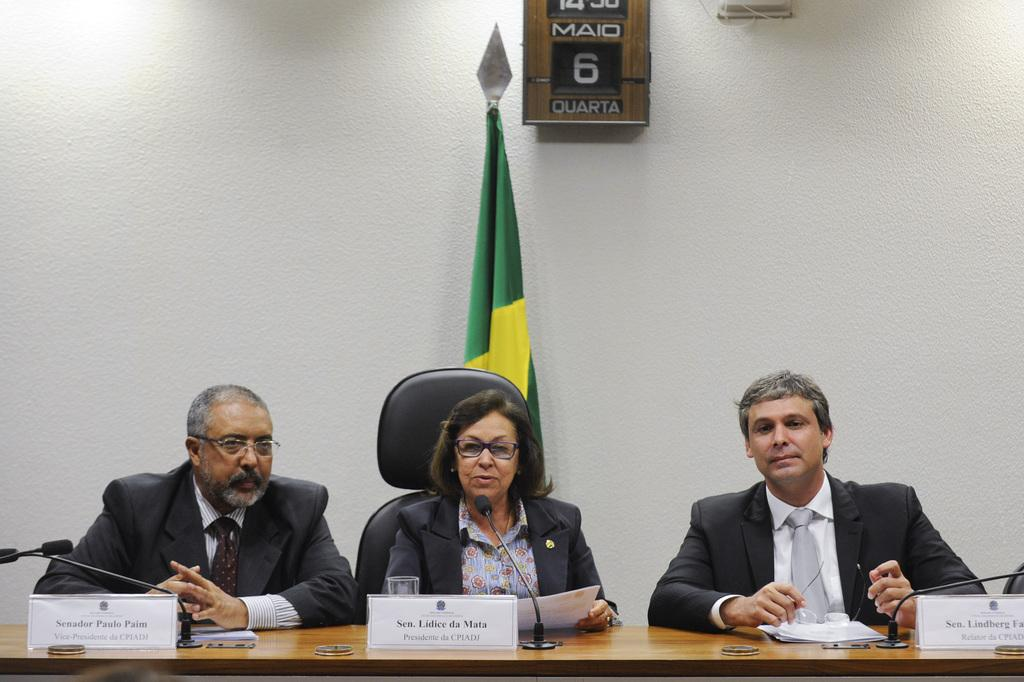How many people are in the image? There are three people in the image. What are the people doing in the image? The people are sitting on chairs. Where are the chairs located in relation to the desk? The chairs are in front of a desk. What items can be seen on the desk? There are name boards and microphones on the desk. What is the tendency of the airport in the image? There is no airport present in the image, so it is not possible to determine its tendency. 